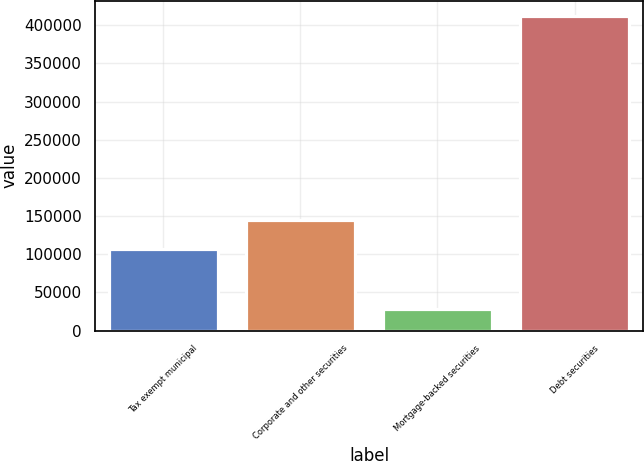<chart> <loc_0><loc_0><loc_500><loc_500><bar_chart><fcel>Tax exempt municipal<fcel>Corporate and other securities<fcel>Mortgage-backed securities<fcel>Debt securities<nl><fcel>106453<fcel>144850<fcel>27684<fcel>411652<nl></chart> 